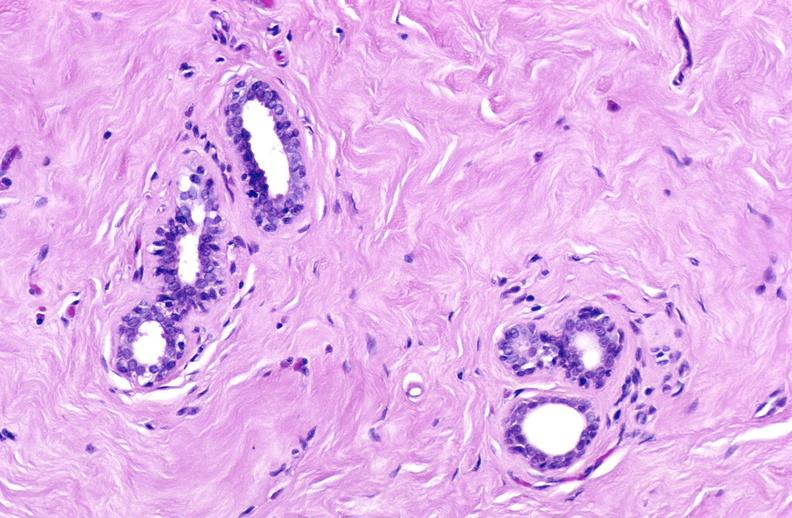what does this image show?
Answer the question using a single word or phrase. Breast 